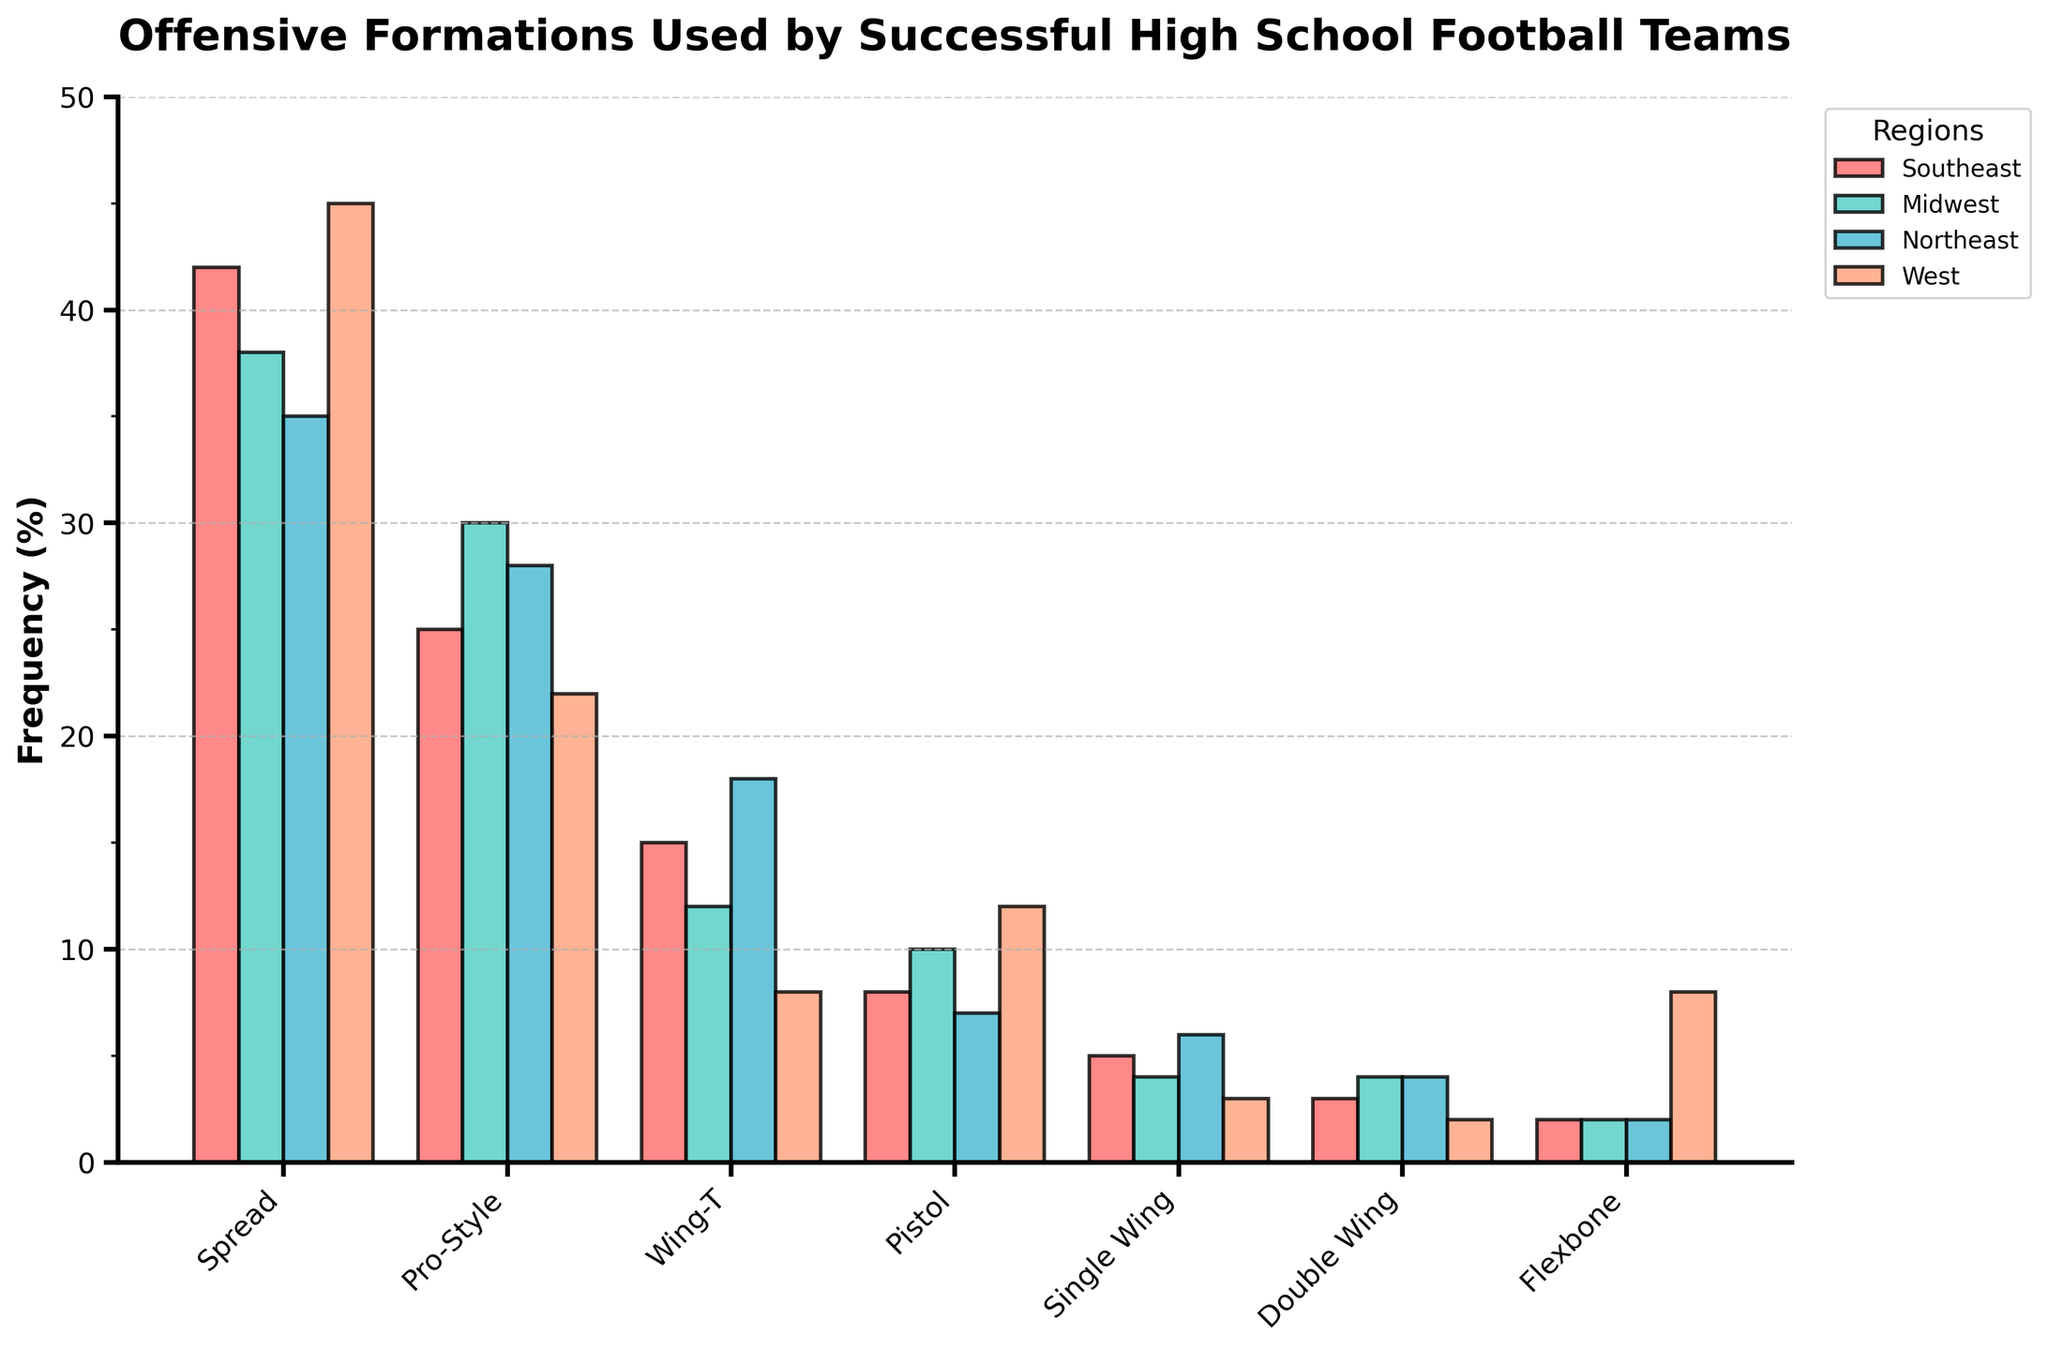What's the most frequently used offensive formation in the Southeast region? Identify the highest bar in the Southeast region by comparing the heights of all bars representing the formations. The highest bar (tallest) will indicate the most frequently used formation.
Answer: Spread (42%) Which region uses the Pro-Style formation the least? Compare the height of all Pro-Style bars across the four regions. The shortest Pro-Style bar indicates the region that uses this formation the least.
Answer: West (22%) Which formation in the Northeast region has the second-highest frequency? Compare the heights of all bars in the Northeast region, select the second tallest bar.
Answer: Pro-Style (28%) Is the Single Wing formation more popular in the Southeast or Midwest region? Compare the heights of the Single Wing bars between the Southeast and Midwest regions, the taller bar indicates the more popular region.
Answer: Southeast (5%) What's the total frequency of the Wing-T formation across all regions? Sum the heights of the Wing-T bars from all regions: Southeast (15) + Midwest (12) + Northeast (18) + West (8)
Answer: 53% Which formation has the highest overall frequency across all regions? Compare the total combined heights of all formations’ bars. The formation whose bars sum up to the highest total across all regions is the answer.
Answer: Spread In terms of usage, how does the Flexbone formation in the West compare to the Southeast? Compare the bar heights of the Flexbone formation between the West and Southeast regions. The region with the taller bar uses the formation more.
Answer: The West uses it more (8%) What is the average frequency of the Pro-Style formation in the Midwest and Northeast regions? Sum the frequencies of the Pro-Style formation in the Midwest (30) and Northeast (28), then divide by 2: (30 + 28) / 2 = 29
Answer: 29% Which formation has the least variation in usage across the four regions? Calculate and compare the range of frequencies for each formation (difference between the highest and lowest values). The formation with the smallest range has the least variation.
Answer: Flexbone (range is 6) How often is the Pistol formation used in the West compared to the Southeast? Compare the bar heights of the Pistol formation between the West and Southeast regions. The region with the taller bar uses the formation more frequently.
Answer: The West uses it more (12%) 